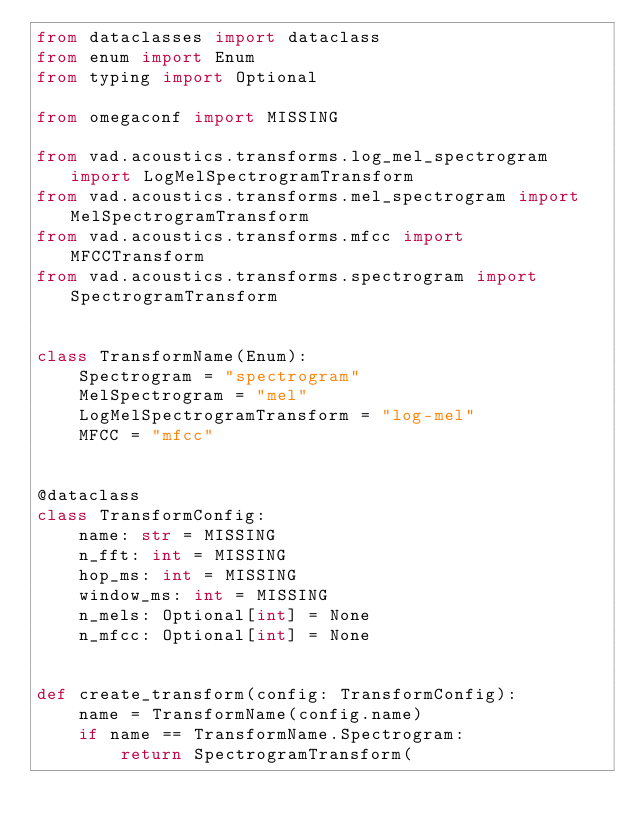<code> <loc_0><loc_0><loc_500><loc_500><_Python_>from dataclasses import dataclass
from enum import Enum
from typing import Optional

from omegaconf import MISSING

from vad.acoustics.transforms.log_mel_spectrogram import LogMelSpectrogramTransform
from vad.acoustics.transforms.mel_spectrogram import MelSpectrogramTransform
from vad.acoustics.transforms.mfcc import MFCCTransform
from vad.acoustics.transforms.spectrogram import SpectrogramTransform


class TransformName(Enum):
    Spectrogram = "spectrogram"
    MelSpectrogram = "mel"
    LogMelSpectrogramTransform = "log-mel"
    MFCC = "mfcc"


@dataclass
class TransformConfig:
    name: str = MISSING
    n_fft: int = MISSING
    hop_ms: int = MISSING
    window_ms: int = MISSING
    n_mels: Optional[int] = None
    n_mfcc: Optional[int] = None


def create_transform(config: TransformConfig):
    name = TransformName(config.name)
    if name == TransformName.Spectrogram:
        return SpectrogramTransform(</code> 